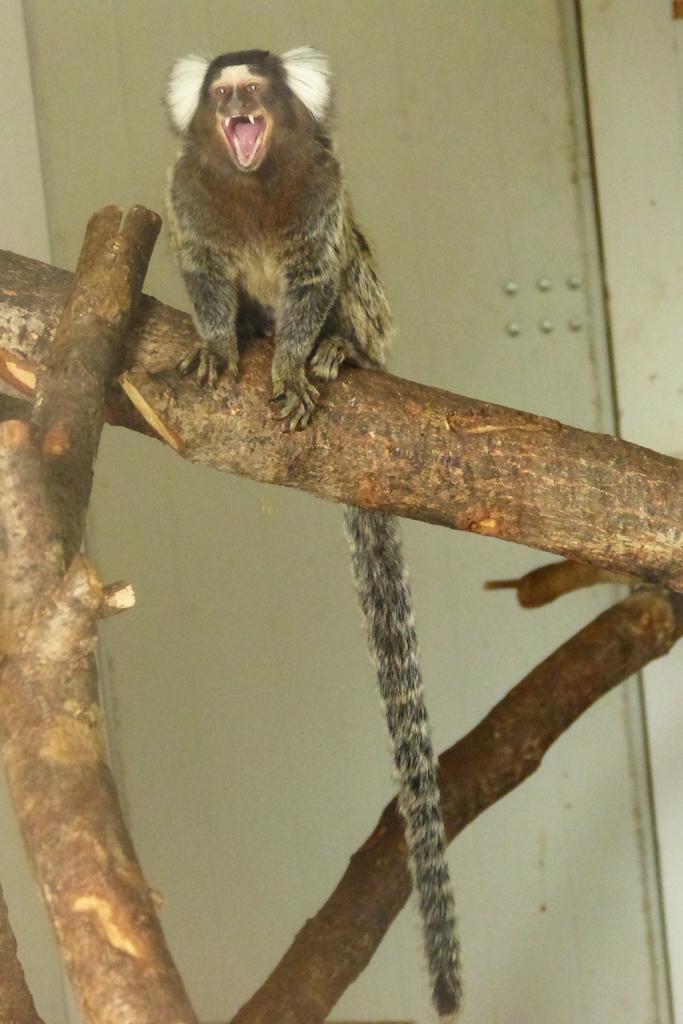Could you give a brief overview of what you see in this image? In this picture I can see an animal is sitting on a tree. In the background I can see a white color wall. 